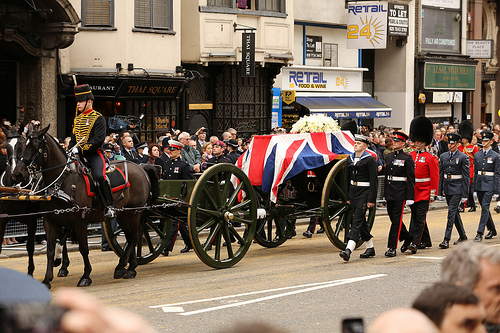Is the green vehicle pulled by the brown animal that is to the left of the man? Yes, the green vehicle is being pulled by a brown horse that is positioned to the left of the man. 